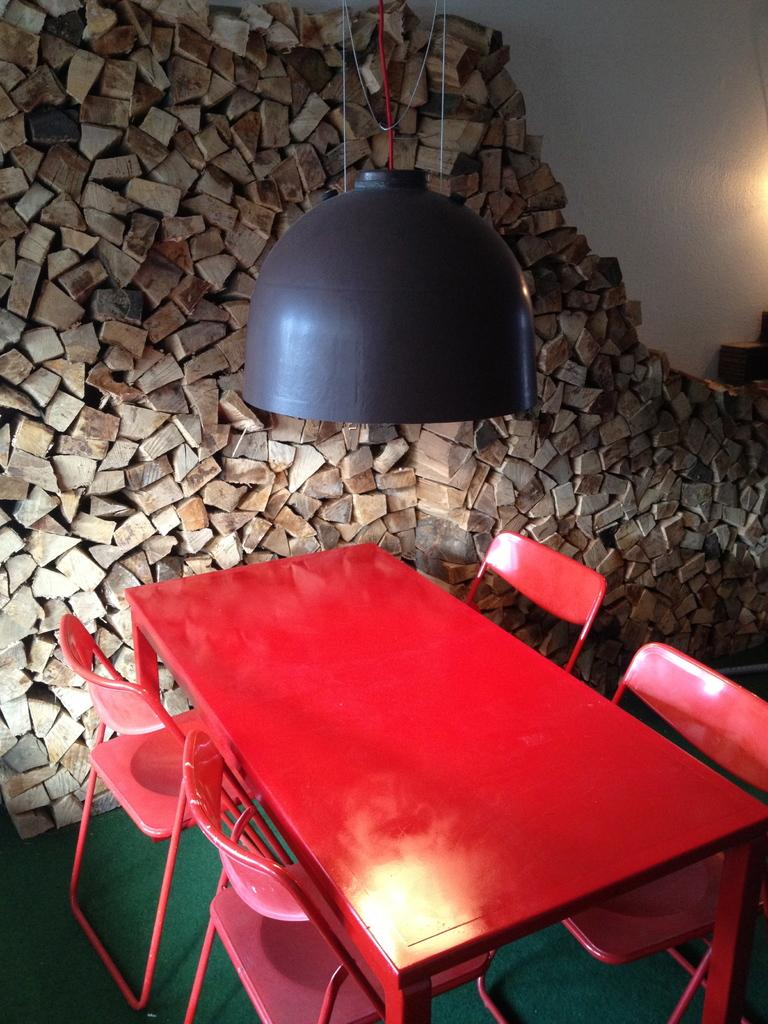What type of furniture is present in the image? There are chairs and a table in the image. What color are the chairs and table? The chairs and table are red in color. What is the source of light in the image? There is a light in front of the chairs and table. What can be seen in the background of the image? There are wooden objects in the background of the image. What color is the wall in the image? The wall is white in color. Can you see any magic happening around the chairs and table in the image? There is no magic present in the image; it is a scene featuring chairs, a table, and other objects. Are there any insects crawling on the chairs or table in the image? There is no indication of insects present on the chairs or table in the image. 